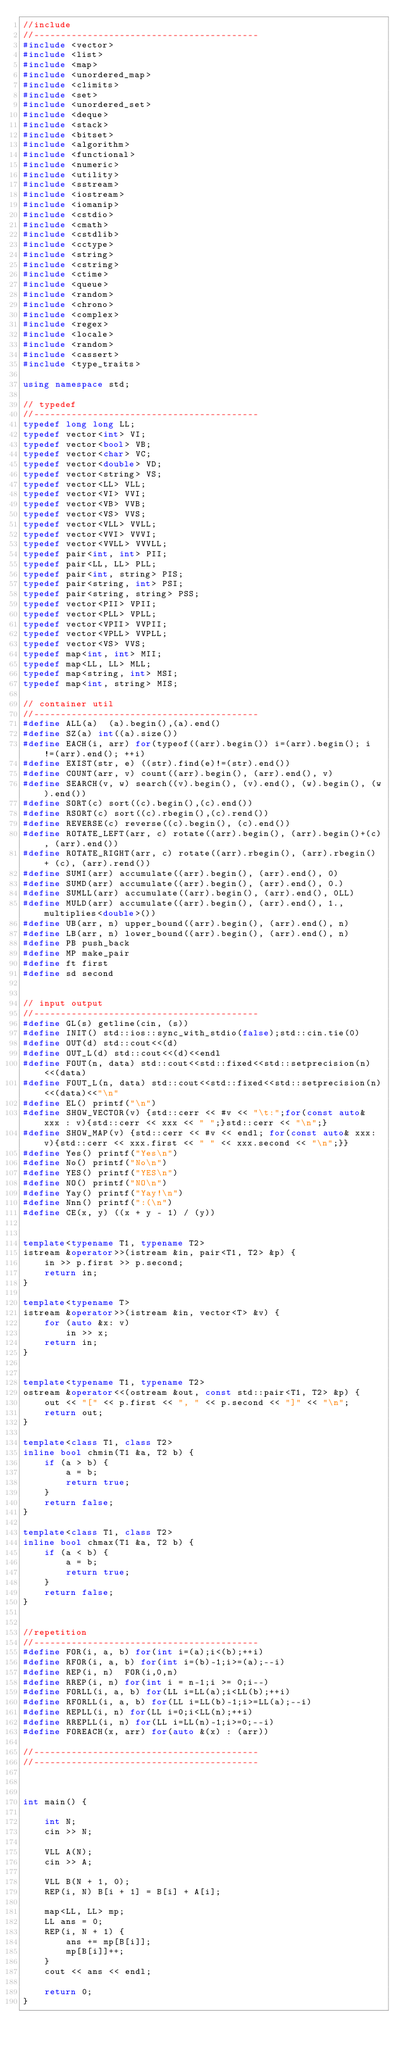Convert code to text. <code><loc_0><loc_0><loc_500><loc_500><_C++_>//include
//------------------------------------------
#include <vector>
#include <list>
#include <map>
#include <unordered_map>
#include <climits>
#include <set>
#include <unordered_set>
#include <deque>
#include <stack>
#include <bitset>
#include <algorithm>
#include <functional>
#include <numeric>
#include <utility>
#include <sstream>
#include <iostream>
#include <iomanip>
#include <cstdio>
#include <cmath>
#include <cstdlib>
#include <cctype>
#include <string>
#include <cstring>
#include <ctime>
#include <queue>
#include <random>
#include <chrono>
#include <complex>
#include <regex>
#include <locale>
#include <random>
#include <cassert>
#include <type_traits>

using namespace std;

// typedef
//------------------------------------------
typedef long long LL;
typedef vector<int> VI;
typedef vector<bool> VB;
typedef vector<char> VC;
typedef vector<double> VD;
typedef vector<string> VS;
typedef vector<LL> VLL;
typedef vector<VI> VVI;
typedef vector<VB> VVB;
typedef vector<VS> VVS;
typedef vector<VLL> VVLL;
typedef vector<VVI> VVVI;
typedef vector<VVLL> VVVLL;
typedef pair<int, int> PII;
typedef pair<LL, LL> PLL;
typedef pair<int, string> PIS;
typedef pair<string, int> PSI;
typedef pair<string, string> PSS;
typedef vector<PII> VPII;
typedef vector<PLL> VPLL;
typedef vector<VPII> VVPII;
typedef vector<VPLL> VVPLL;
typedef vector<VS> VVS;
typedef map<int, int> MII;
typedef map<LL, LL> MLL;
typedef map<string, int> MSI;
typedef map<int, string> MIS;

// container util
//------------------------------------------
#define ALL(a)  (a).begin(),(a).end()
#define SZ(a) int((a).size())
#define EACH(i, arr) for(typeof((arr).begin()) i=(arr).begin(); i!=(arr).end(); ++i)
#define EXIST(str, e) ((str).find(e)!=(str).end())
#define COUNT(arr, v) count((arr).begin(), (arr).end(), v)
#define SEARCH(v, w) search((v).begin(), (v).end(), (w).begin(), (w).end())
#define SORT(c) sort((c).begin(),(c).end())
#define RSORT(c) sort((c).rbegin(),(c).rend())
#define REVERSE(c) reverse((c).begin(), (c).end())
#define ROTATE_LEFT(arr, c) rotate((arr).begin(), (arr).begin()+(c), (arr).end())
#define ROTATE_RIGHT(arr, c) rotate((arr).rbegin(), (arr).rbegin() + (c), (arr).rend())
#define SUMI(arr) accumulate((arr).begin(), (arr).end(), 0)
#define SUMD(arr) accumulate((arr).begin(), (arr).end(), 0.)
#define SUMLL(arr) accumulate((arr).begin(), (arr).end(), 0LL)
#define MULD(arr) accumulate((arr).begin(), (arr).end(), 1., multiplies<double>())
#define UB(arr, n) upper_bound((arr).begin(), (arr).end(), n)
#define LB(arr, n) lower_bound((arr).begin(), (arr).end(), n)
#define PB push_back
#define MP make_pair
#define ft first
#define sd second


// input output
//------------------------------------------
#define GL(s) getline(cin, (s))
#define INIT() std::ios::sync_with_stdio(false);std::cin.tie(0)
#define OUT(d) std::cout<<(d)
#define OUT_L(d) std::cout<<(d)<<endl
#define FOUT(n, data) std::cout<<std::fixed<<std::setprecision(n)<<(data)
#define FOUT_L(n, data) std::cout<<std::fixed<<std::setprecision(n)<<(data)<<"\n"
#define EL() printf("\n")
#define SHOW_VECTOR(v) {std::cerr << #v << "\t:";for(const auto& xxx : v){std::cerr << xxx << " ";}std::cerr << "\n";}
#define SHOW_MAP(v) {std::cerr << #v << endl; for(const auto& xxx: v){std::cerr << xxx.first << " " << xxx.second << "\n";}}
#define Yes() printf("Yes\n")
#define No() printf("No\n")
#define YES() printf("YES\n")
#define NO() printf("NO\n")
#define Yay() printf("Yay!\n")
#define Nnn() printf(":(\n")
#define CE(x, y) ((x + y - 1) / (y))


template<typename T1, typename T2>
istream &operator>>(istream &in, pair<T1, T2> &p) {
    in >> p.first >> p.second;
    return in;
}

template<typename T>
istream &operator>>(istream &in, vector<T> &v) {
    for (auto &x: v)
        in >> x;
    return in;
}


template<typename T1, typename T2>
ostream &operator<<(ostream &out, const std::pair<T1, T2> &p) {
    out << "[" << p.first << ", " << p.second << "]" << "\n";
    return out;
}

template<class T1, class T2>
inline bool chmin(T1 &a, T2 b) {
    if (a > b) {
        a = b;
        return true;
    }
    return false;
}

template<class T1, class T2>
inline bool chmax(T1 &a, T2 b) {
    if (a < b) {
        a = b;
        return true;
    }
    return false;
}


//repetition
//------------------------------------------
#define FOR(i, a, b) for(int i=(a);i<(b);++i)
#define RFOR(i, a, b) for(int i=(b)-1;i>=(a);--i)
#define REP(i, n)  FOR(i,0,n)
#define RREP(i, n) for(int i = n-1;i >= 0;i--)
#define FORLL(i, a, b) for(LL i=LL(a);i<LL(b);++i)
#define RFORLL(i, a, b) for(LL i=LL(b)-1;i>=LL(a);--i)
#define REPLL(i, n) for(LL i=0;i<LL(n);++i)
#define RREPLL(i, n) for(LL i=LL(n)-1;i>=0;--i)
#define FOREACH(x, arr) for(auto &(x) : (arr))

//------------------------------------------
//------------------------------------------



int main() {

    int N;
    cin >> N;

    VLL A(N);
    cin >> A;

    VLL B(N + 1, 0);
    REP(i, N) B[i + 1] = B[i] + A[i];

    map<LL, LL> mp;
    LL ans = 0;
    REP(i, N + 1) {
        ans += mp[B[i]];
        mp[B[i]]++;
    }
    cout << ans << endl;

    return 0;
}
















































</code> 